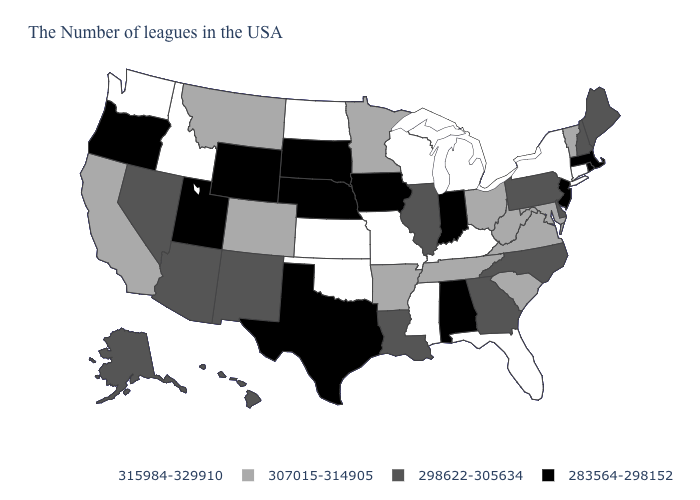Name the states that have a value in the range 315984-329910?
Short answer required. Connecticut, New York, Florida, Michigan, Kentucky, Wisconsin, Mississippi, Missouri, Kansas, Oklahoma, North Dakota, Idaho, Washington. What is the value of Texas?
Quick response, please. 283564-298152. What is the value of Texas?
Give a very brief answer. 283564-298152. Does Illinois have the highest value in the MidWest?
Short answer required. No. Name the states that have a value in the range 307015-314905?
Give a very brief answer. Vermont, Maryland, Virginia, South Carolina, West Virginia, Ohio, Tennessee, Arkansas, Minnesota, Colorado, Montana, California. What is the lowest value in states that border Wyoming?
Keep it brief. 283564-298152. Name the states that have a value in the range 307015-314905?
Quick response, please. Vermont, Maryland, Virginia, South Carolina, West Virginia, Ohio, Tennessee, Arkansas, Minnesota, Colorado, Montana, California. Which states have the lowest value in the USA?
Be succinct. Massachusetts, Rhode Island, New Jersey, Indiana, Alabama, Iowa, Nebraska, Texas, South Dakota, Wyoming, Utah, Oregon. How many symbols are there in the legend?
Concise answer only. 4. What is the lowest value in the USA?
Quick response, please. 283564-298152. Name the states that have a value in the range 315984-329910?
Be succinct. Connecticut, New York, Florida, Michigan, Kentucky, Wisconsin, Mississippi, Missouri, Kansas, Oklahoma, North Dakota, Idaho, Washington. Which states have the lowest value in the USA?
Write a very short answer. Massachusetts, Rhode Island, New Jersey, Indiana, Alabama, Iowa, Nebraska, Texas, South Dakota, Wyoming, Utah, Oregon. What is the lowest value in states that border Michigan?
Write a very short answer. 283564-298152. Among the states that border Arizona , which have the lowest value?
Write a very short answer. Utah. Does Kansas have the highest value in the USA?
Give a very brief answer. Yes. 